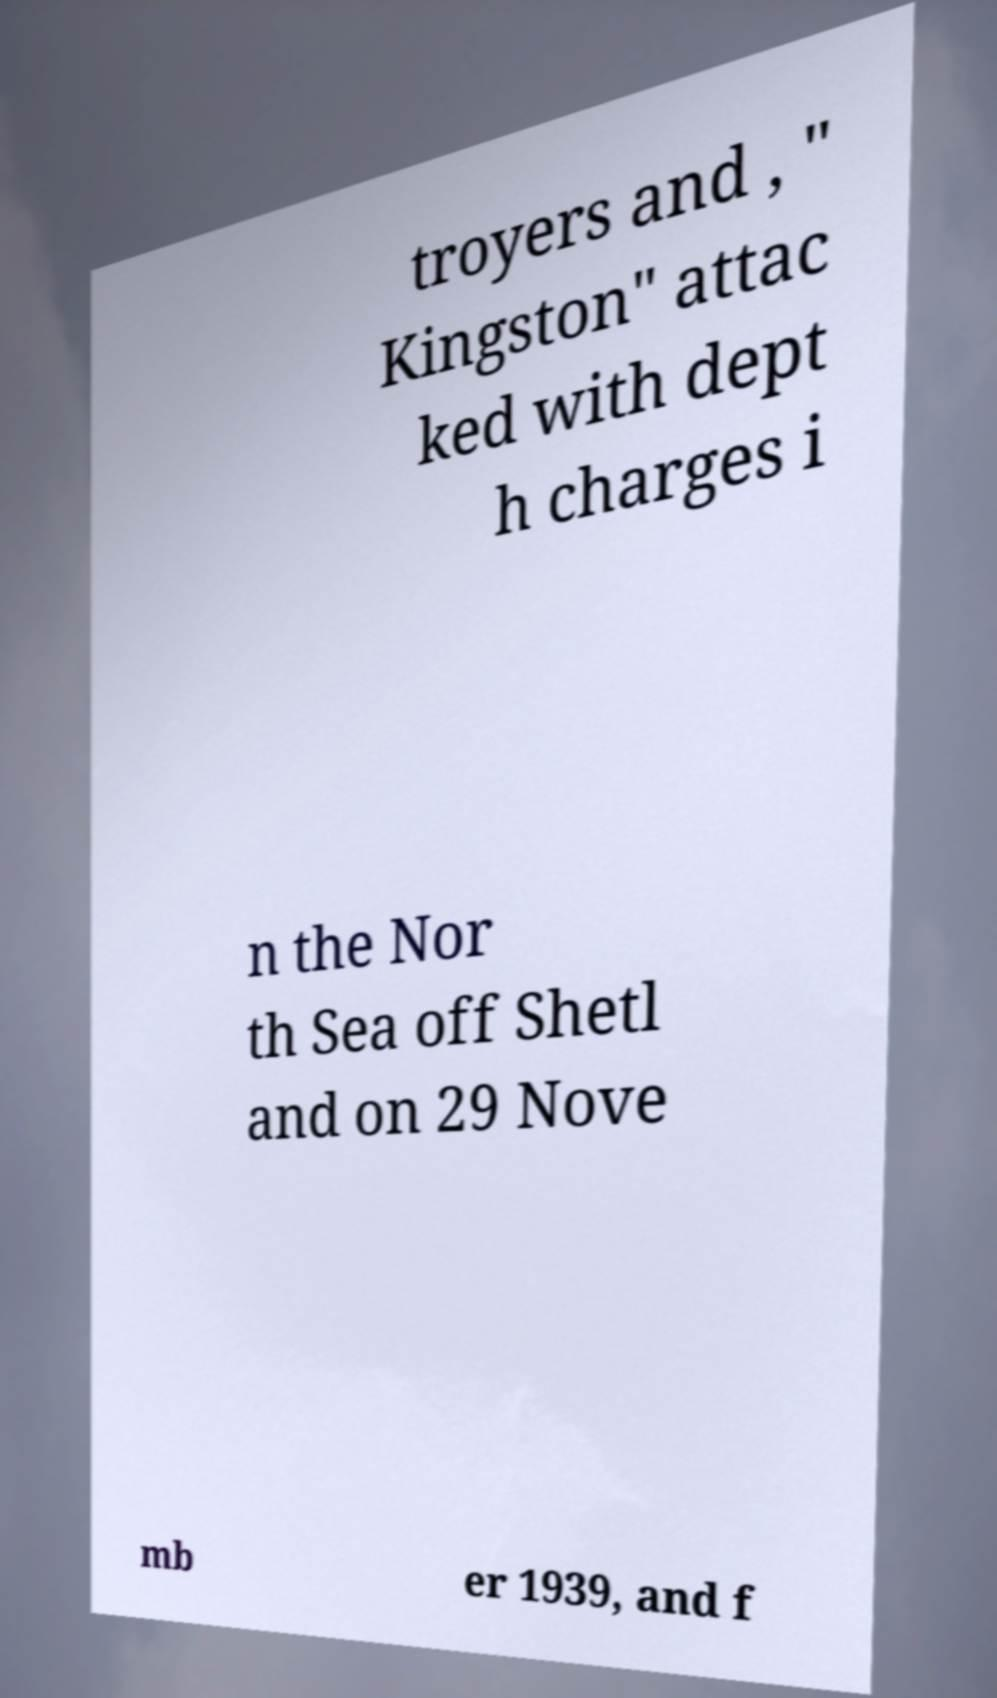Can you read and provide the text displayed in the image?This photo seems to have some interesting text. Can you extract and type it out for me? troyers and , " Kingston" attac ked with dept h charges i n the Nor th Sea off Shetl and on 29 Nove mb er 1939, and f 